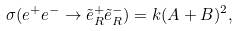Convert formula to latex. <formula><loc_0><loc_0><loc_500><loc_500>\sigma ( e ^ { + } e ^ { - } \rightarrow \tilde { e } ^ { + } _ { R } \tilde { e } ^ { - } _ { R } ) = k ( A + B ) ^ { 2 } , \,</formula> 